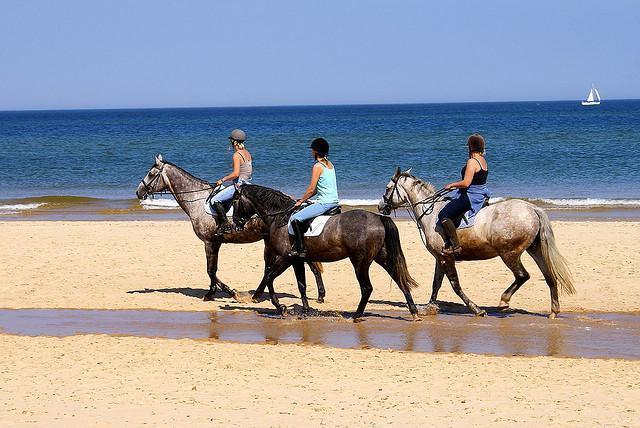How many horses are on the beach?
Give a very brief answer. 3. How many horses can be seen?
Give a very brief answer. 3. How many people are there?
Give a very brief answer. 2. How many cars are heading toward the train?
Give a very brief answer. 0. 